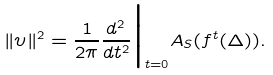<formula> <loc_0><loc_0><loc_500><loc_500>\| \upsilon \| ^ { 2 } = \frac { 1 } { 2 \pi } \frac { d ^ { 2 } } { d t ^ { 2 } } \Big | _ { t = 0 } A _ { S } ( f ^ { t } ( \Delta ) ) .</formula> 